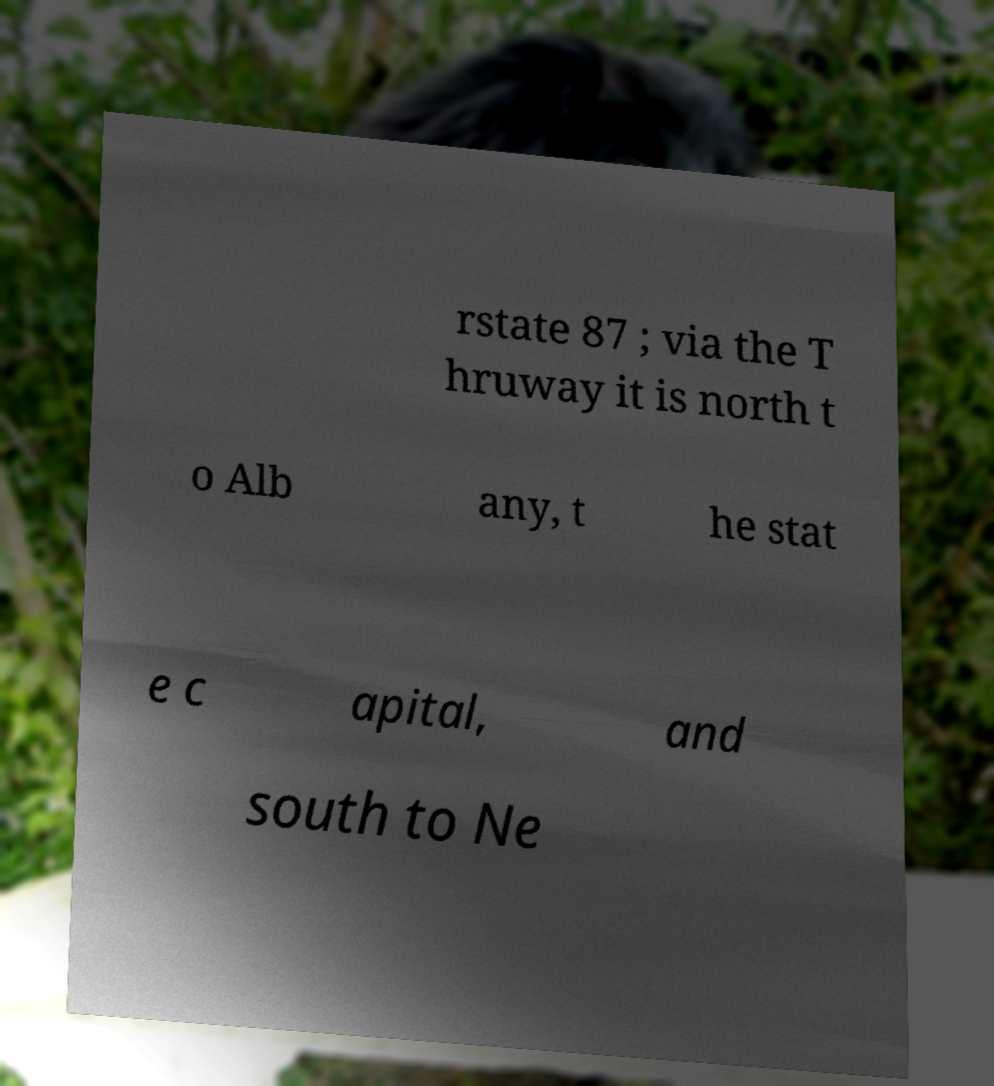Can you accurately transcribe the text from the provided image for me? rstate 87 ; via the T hruway it is north t o Alb any, t he stat e c apital, and south to Ne 